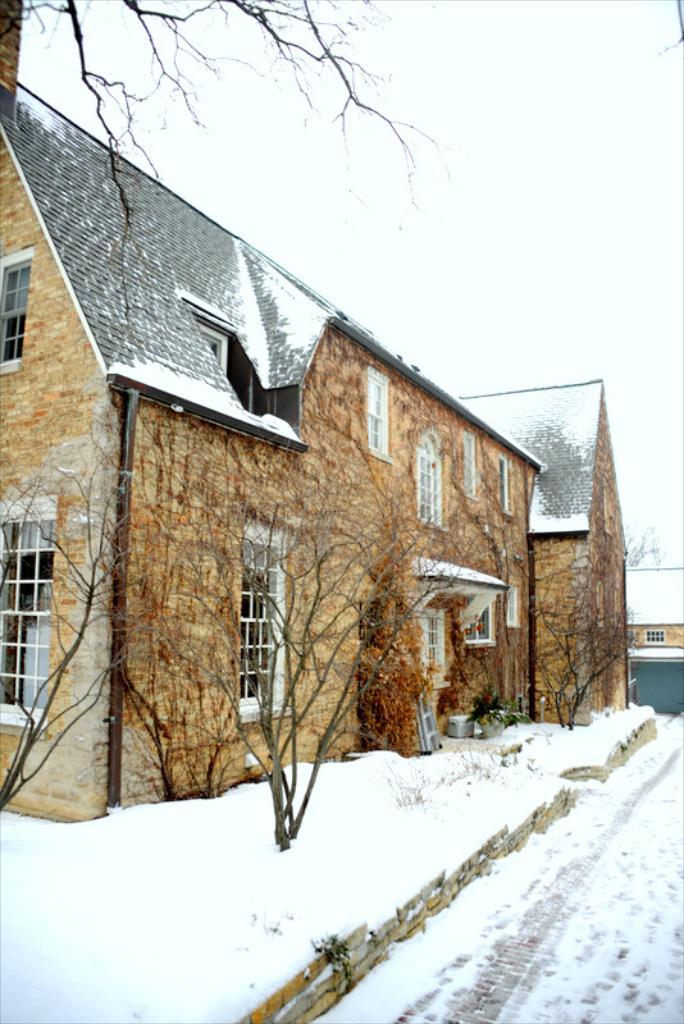What type of structures can be seen in the image? There are houses in the image. What is the condition of the trees in the image? Trees covered with snow are visible in the image. What type of mint can be seen growing near the houses in the image? There is no mint visible in the image; the focus is on the houses and the snow-covered trees. 